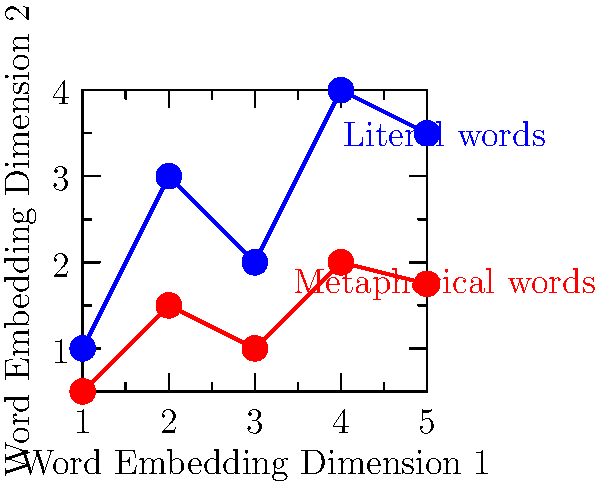Based on the image-based word embeddings shown in the graph, which of the following statements is most likely true about detecting metaphors in poetry using this method? To answer this question, let's analyze the graph step-by-step:

1. The graph shows two sets of points plotted in a 2D space, representing word embeddings along two dimensions.

2. The blue points represent literal words, while the red points represent metaphorical words.

3. We can observe that:
   a. The blue points (literal words) generally have higher values on Dimension 2.
   b. The red points (metaphorical words) generally have lower values on Dimension 2.
   c. There is some overlap between the two sets of points, but they form distinct clusters.

4. This distribution suggests that image-based word embeddings can differentiate between literal and metaphorical words to some extent.

5. However, the overlap between the two sets of points indicates that the separation is not perfect, and there may be some ambiguity in classification.

6. The distinct clustering pattern suggests that a machine learning algorithm could be trained to differentiate between literal and metaphorical words based on their positions in this embedding space.

7. The separation is most pronounced along Dimension 2, indicating that this dimension might be more informative for metaphor detection.

Given these observations, we can conclude that image-based word embeddings show promise for detecting metaphors in poetry, but the method is likely to have some limitations due to the partial overlap between literal and metaphorical word representations.
Answer: Image-based word embeddings can distinguish metaphorical from literal words with moderate accuracy, but some ambiguity remains. 